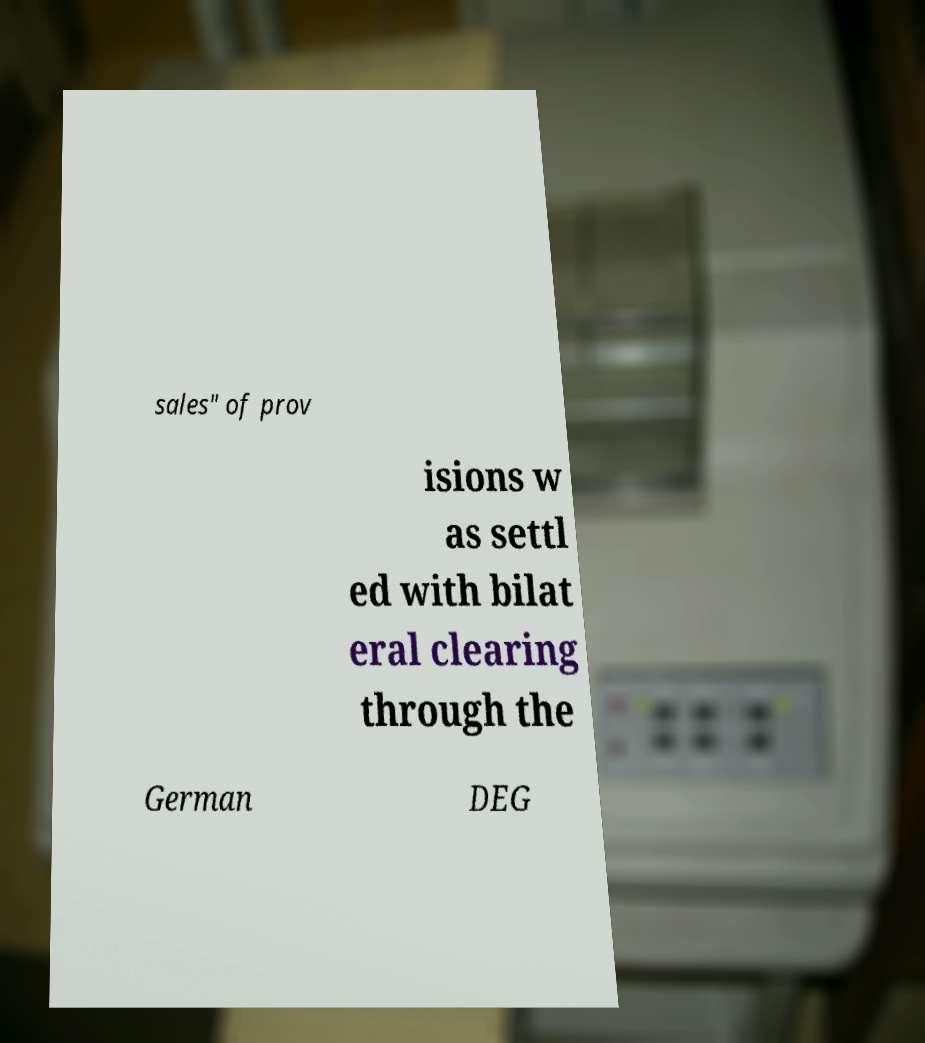Please read and relay the text visible in this image. What does it say? sales" of prov isions w as settl ed with bilat eral clearing through the German DEG 